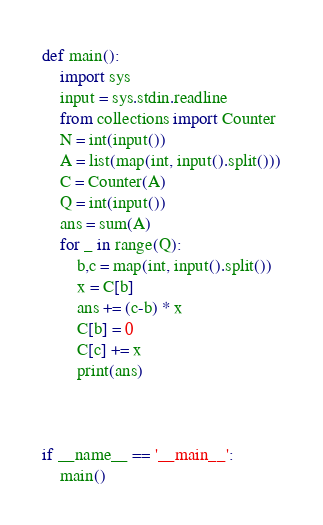<code> <loc_0><loc_0><loc_500><loc_500><_Python_>def main():
    import sys
    input = sys.stdin.readline
    from collections import Counter
    N = int(input())
    A = list(map(int, input().split()))
    C = Counter(A)
    Q = int(input())
    ans = sum(A)
    for _ in range(Q):
        b,c = map(int, input().split())
        x = C[b]
        ans += (c-b) * x
        C[b] = 0
        C[c] += x
        print(ans)



if __name__ == '__main__':
    main()</code> 